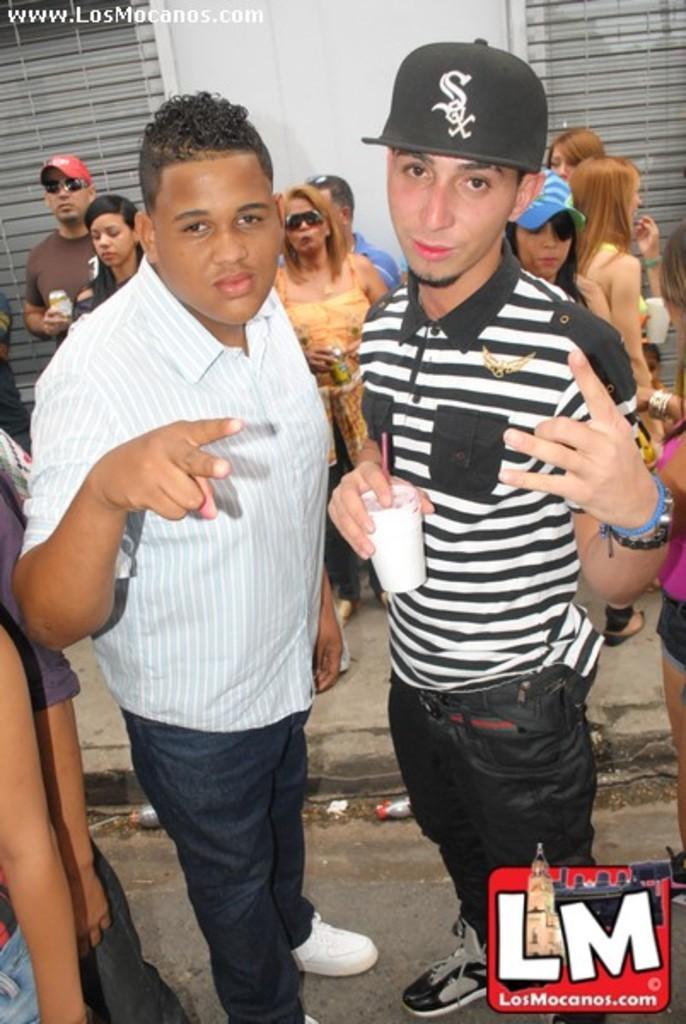Can you describe this image briefly? This picture describes about group of people, they are standing, few people wore caps and few people wore spectacles, in the middle of the image we can see a man he is holding a cup. 